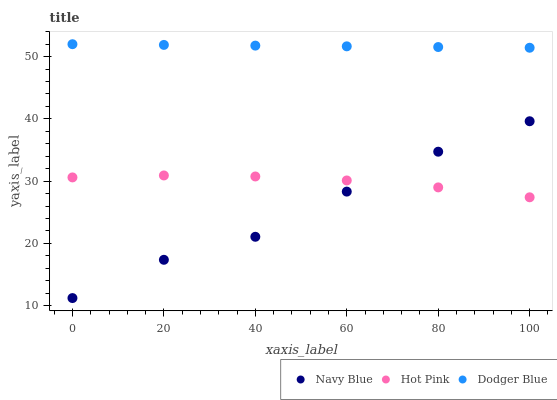Does Navy Blue have the minimum area under the curve?
Answer yes or no. Yes. Does Dodger Blue have the maximum area under the curve?
Answer yes or no. Yes. Does Hot Pink have the minimum area under the curve?
Answer yes or no. No. Does Hot Pink have the maximum area under the curve?
Answer yes or no. No. Is Dodger Blue the smoothest?
Answer yes or no. Yes. Is Navy Blue the roughest?
Answer yes or no. Yes. Is Hot Pink the smoothest?
Answer yes or no. No. Is Hot Pink the roughest?
Answer yes or no. No. Does Navy Blue have the lowest value?
Answer yes or no. Yes. Does Hot Pink have the lowest value?
Answer yes or no. No. Does Dodger Blue have the highest value?
Answer yes or no. Yes. Does Hot Pink have the highest value?
Answer yes or no. No. Is Navy Blue less than Dodger Blue?
Answer yes or no. Yes. Is Dodger Blue greater than Hot Pink?
Answer yes or no. Yes. Does Navy Blue intersect Hot Pink?
Answer yes or no. Yes. Is Navy Blue less than Hot Pink?
Answer yes or no. No. Is Navy Blue greater than Hot Pink?
Answer yes or no. No. Does Navy Blue intersect Dodger Blue?
Answer yes or no. No. 